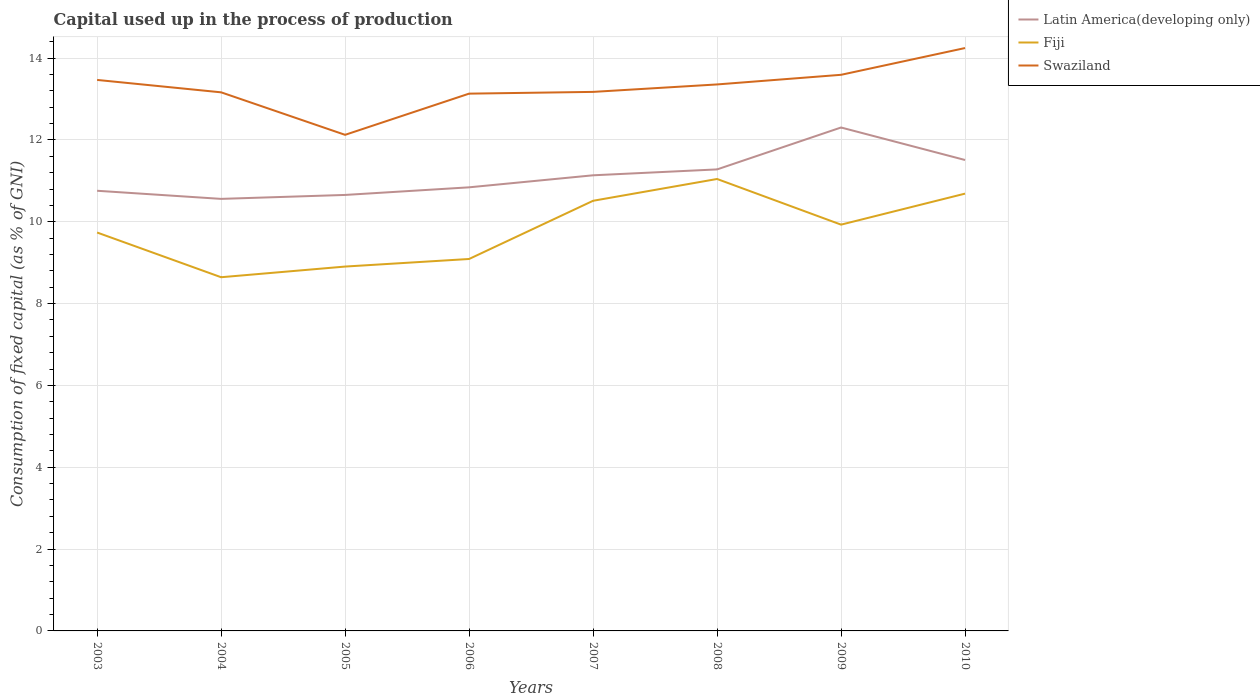Across all years, what is the maximum capital used up in the process of production in Latin America(developing only)?
Make the answer very short. 10.56. In which year was the capital used up in the process of production in Fiji maximum?
Offer a very short reply. 2004. What is the total capital used up in the process of production in Swaziland in the graph?
Your answer should be very brief. -0.23. What is the difference between the highest and the second highest capital used up in the process of production in Fiji?
Give a very brief answer. 2.4. What is the difference between the highest and the lowest capital used up in the process of production in Latin America(developing only)?
Give a very brief answer. 4. Is the capital used up in the process of production in Swaziland strictly greater than the capital used up in the process of production in Latin America(developing only) over the years?
Ensure brevity in your answer.  No. How many years are there in the graph?
Keep it short and to the point. 8. What is the title of the graph?
Your answer should be compact. Capital used up in the process of production. What is the label or title of the Y-axis?
Keep it short and to the point. Consumption of fixed capital (as % of GNI). What is the Consumption of fixed capital (as % of GNI) of Latin America(developing only) in 2003?
Ensure brevity in your answer.  10.76. What is the Consumption of fixed capital (as % of GNI) in Fiji in 2003?
Give a very brief answer. 9.74. What is the Consumption of fixed capital (as % of GNI) of Swaziland in 2003?
Keep it short and to the point. 13.47. What is the Consumption of fixed capital (as % of GNI) of Latin America(developing only) in 2004?
Give a very brief answer. 10.56. What is the Consumption of fixed capital (as % of GNI) in Fiji in 2004?
Ensure brevity in your answer.  8.64. What is the Consumption of fixed capital (as % of GNI) of Swaziland in 2004?
Your response must be concise. 13.16. What is the Consumption of fixed capital (as % of GNI) of Latin America(developing only) in 2005?
Offer a very short reply. 10.66. What is the Consumption of fixed capital (as % of GNI) of Fiji in 2005?
Give a very brief answer. 8.91. What is the Consumption of fixed capital (as % of GNI) of Swaziland in 2005?
Ensure brevity in your answer.  12.13. What is the Consumption of fixed capital (as % of GNI) in Latin America(developing only) in 2006?
Give a very brief answer. 10.84. What is the Consumption of fixed capital (as % of GNI) in Fiji in 2006?
Ensure brevity in your answer.  9.09. What is the Consumption of fixed capital (as % of GNI) of Swaziland in 2006?
Keep it short and to the point. 13.13. What is the Consumption of fixed capital (as % of GNI) in Latin America(developing only) in 2007?
Your response must be concise. 11.14. What is the Consumption of fixed capital (as % of GNI) in Fiji in 2007?
Offer a very short reply. 10.51. What is the Consumption of fixed capital (as % of GNI) of Swaziland in 2007?
Your response must be concise. 13.18. What is the Consumption of fixed capital (as % of GNI) in Latin America(developing only) in 2008?
Offer a very short reply. 11.28. What is the Consumption of fixed capital (as % of GNI) in Fiji in 2008?
Provide a succinct answer. 11.05. What is the Consumption of fixed capital (as % of GNI) in Swaziland in 2008?
Provide a short and direct response. 13.36. What is the Consumption of fixed capital (as % of GNI) of Latin America(developing only) in 2009?
Offer a terse response. 12.3. What is the Consumption of fixed capital (as % of GNI) of Fiji in 2009?
Your answer should be very brief. 9.93. What is the Consumption of fixed capital (as % of GNI) in Swaziland in 2009?
Your answer should be compact. 13.59. What is the Consumption of fixed capital (as % of GNI) of Latin America(developing only) in 2010?
Make the answer very short. 11.51. What is the Consumption of fixed capital (as % of GNI) in Fiji in 2010?
Offer a terse response. 10.69. What is the Consumption of fixed capital (as % of GNI) of Swaziland in 2010?
Keep it short and to the point. 14.25. Across all years, what is the maximum Consumption of fixed capital (as % of GNI) of Latin America(developing only)?
Keep it short and to the point. 12.3. Across all years, what is the maximum Consumption of fixed capital (as % of GNI) of Fiji?
Ensure brevity in your answer.  11.05. Across all years, what is the maximum Consumption of fixed capital (as % of GNI) of Swaziland?
Ensure brevity in your answer.  14.25. Across all years, what is the minimum Consumption of fixed capital (as % of GNI) of Latin America(developing only)?
Ensure brevity in your answer.  10.56. Across all years, what is the minimum Consumption of fixed capital (as % of GNI) of Fiji?
Offer a very short reply. 8.64. Across all years, what is the minimum Consumption of fixed capital (as % of GNI) in Swaziland?
Offer a very short reply. 12.13. What is the total Consumption of fixed capital (as % of GNI) in Latin America(developing only) in the graph?
Your answer should be very brief. 89.05. What is the total Consumption of fixed capital (as % of GNI) in Fiji in the graph?
Keep it short and to the point. 78.56. What is the total Consumption of fixed capital (as % of GNI) of Swaziland in the graph?
Keep it short and to the point. 106.26. What is the difference between the Consumption of fixed capital (as % of GNI) of Latin America(developing only) in 2003 and that in 2004?
Ensure brevity in your answer.  0.2. What is the difference between the Consumption of fixed capital (as % of GNI) of Fiji in 2003 and that in 2004?
Provide a succinct answer. 1.09. What is the difference between the Consumption of fixed capital (as % of GNI) of Swaziland in 2003 and that in 2004?
Make the answer very short. 0.3. What is the difference between the Consumption of fixed capital (as % of GNI) in Latin America(developing only) in 2003 and that in 2005?
Your response must be concise. 0.1. What is the difference between the Consumption of fixed capital (as % of GNI) of Fiji in 2003 and that in 2005?
Offer a very short reply. 0.83. What is the difference between the Consumption of fixed capital (as % of GNI) of Swaziland in 2003 and that in 2005?
Give a very brief answer. 1.34. What is the difference between the Consumption of fixed capital (as % of GNI) of Latin America(developing only) in 2003 and that in 2006?
Your answer should be very brief. -0.08. What is the difference between the Consumption of fixed capital (as % of GNI) of Fiji in 2003 and that in 2006?
Keep it short and to the point. 0.65. What is the difference between the Consumption of fixed capital (as % of GNI) in Swaziland in 2003 and that in 2006?
Provide a succinct answer. 0.34. What is the difference between the Consumption of fixed capital (as % of GNI) of Latin America(developing only) in 2003 and that in 2007?
Your answer should be very brief. -0.38. What is the difference between the Consumption of fixed capital (as % of GNI) in Fiji in 2003 and that in 2007?
Offer a terse response. -0.78. What is the difference between the Consumption of fixed capital (as % of GNI) of Swaziland in 2003 and that in 2007?
Provide a succinct answer. 0.29. What is the difference between the Consumption of fixed capital (as % of GNI) in Latin America(developing only) in 2003 and that in 2008?
Offer a terse response. -0.52. What is the difference between the Consumption of fixed capital (as % of GNI) in Fiji in 2003 and that in 2008?
Provide a short and direct response. -1.31. What is the difference between the Consumption of fixed capital (as % of GNI) in Swaziland in 2003 and that in 2008?
Make the answer very short. 0.11. What is the difference between the Consumption of fixed capital (as % of GNI) of Latin America(developing only) in 2003 and that in 2009?
Your answer should be very brief. -1.55. What is the difference between the Consumption of fixed capital (as % of GNI) of Fiji in 2003 and that in 2009?
Provide a succinct answer. -0.19. What is the difference between the Consumption of fixed capital (as % of GNI) of Swaziland in 2003 and that in 2009?
Provide a short and direct response. -0.13. What is the difference between the Consumption of fixed capital (as % of GNI) in Latin America(developing only) in 2003 and that in 2010?
Ensure brevity in your answer.  -0.75. What is the difference between the Consumption of fixed capital (as % of GNI) in Fiji in 2003 and that in 2010?
Provide a succinct answer. -0.95. What is the difference between the Consumption of fixed capital (as % of GNI) in Swaziland in 2003 and that in 2010?
Offer a very short reply. -0.78. What is the difference between the Consumption of fixed capital (as % of GNI) in Latin America(developing only) in 2004 and that in 2005?
Ensure brevity in your answer.  -0.1. What is the difference between the Consumption of fixed capital (as % of GNI) of Fiji in 2004 and that in 2005?
Provide a succinct answer. -0.26. What is the difference between the Consumption of fixed capital (as % of GNI) in Swaziland in 2004 and that in 2005?
Give a very brief answer. 1.04. What is the difference between the Consumption of fixed capital (as % of GNI) in Latin America(developing only) in 2004 and that in 2006?
Keep it short and to the point. -0.28. What is the difference between the Consumption of fixed capital (as % of GNI) in Fiji in 2004 and that in 2006?
Provide a short and direct response. -0.45. What is the difference between the Consumption of fixed capital (as % of GNI) of Swaziland in 2004 and that in 2006?
Offer a very short reply. 0.03. What is the difference between the Consumption of fixed capital (as % of GNI) in Latin America(developing only) in 2004 and that in 2007?
Give a very brief answer. -0.58. What is the difference between the Consumption of fixed capital (as % of GNI) of Fiji in 2004 and that in 2007?
Give a very brief answer. -1.87. What is the difference between the Consumption of fixed capital (as % of GNI) of Swaziland in 2004 and that in 2007?
Provide a succinct answer. -0.01. What is the difference between the Consumption of fixed capital (as % of GNI) of Latin America(developing only) in 2004 and that in 2008?
Provide a short and direct response. -0.72. What is the difference between the Consumption of fixed capital (as % of GNI) of Fiji in 2004 and that in 2008?
Provide a short and direct response. -2.4. What is the difference between the Consumption of fixed capital (as % of GNI) in Swaziland in 2004 and that in 2008?
Provide a succinct answer. -0.19. What is the difference between the Consumption of fixed capital (as % of GNI) of Latin America(developing only) in 2004 and that in 2009?
Provide a short and direct response. -1.74. What is the difference between the Consumption of fixed capital (as % of GNI) in Fiji in 2004 and that in 2009?
Provide a short and direct response. -1.29. What is the difference between the Consumption of fixed capital (as % of GNI) of Swaziland in 2004 and that in 2009?
Make the answer very short. -0.43. What is the difference between the Consumption of fixed capital (as % of GNI) of Latin America(developing only) in 2004 and that in 2010?
Your response must be concise. -0.95. What is the difference between the Consumption of fixed capital (as % of GNI) of Fiji in 2004 and that in 2010?
Your response must be concise. -2.04. What is the difference between the Consumption of fixed capital (as % of GNI) of Swaziland in 2004 and that in 2010?
Provide a succinct answer. -1.08. What is the difference between the Consumption of fixed capital (as % of GNI) in Latin America(developing only) in 2005 and that in 2006?
Your answer should be very brief. -0.19. What is the difference between the Consumption of fixed capital (as % of GNI) of Fiji in 2005 and that in 2006?
Provide a short and direct response. -0.18. What is the difference between the Consumption of fixed capital (as % of GNI) in Swaziland in 2005 and that in 2006?
Provide a succinct answer. -1.01. What is the difference between the Consumption of fixed capital (as % of GNI) of Latin America(developing only) in 2005 and that in 2007?
Keep it short and to the point. -0.48. What is the difference between the Consumption of fixed capital (as % of GNI) of Fiji in 2005 and that in 2007?
Your response must be concise. -1.61. What is the difference between the Consumption of fixed capital (as % of GNI) of Swaziland in 2005 and that in 2007?
Your response must be concise. -1.05. What is the difference between the Consumption of fixed capital (as % of GNI) of Latin America(developing only) in 2005 and that in 2008?
Provide a short and direct response. -0.62. What is the difference between the Consumption of fixed capital (as % of GNI) in Fiji in 2005 and that in 2008?
Provide a short and direct response. -2.14. What is the difference between the Consumption of fixed capital (as % of GNI) of Swaziland in 2005 and that in 2008?
Ensure brevity in your answer.  -1.23. What is the difference between the Consumption of fixed capital (as % of GNI) of Latin America(developing only) in 2005 and that in 2009?
Make the answer very short. -1.65. What is the difference between the Consumption of fixed capital (as % of GNI) of Fiji in 2005 and that in 2009?
Make the answer very short. -1.02. What is the difference between the Consumption of fixed capital (as % of GNI) in Swaziland in 2005 and that in 2009?
Give a very brief answer. -1.47. What is the difference between the Consumption of fixed capital (as % of GNI) of Latin America(developing only) in 2005 and that in 2010?
Offer a terse response. -0.85. What is the difference between the Consumption of fixed capital (as % of GNI) of Fiji in 2005 and that in 2010?
Provide a short and direct response. -1.78. What is the difference between the Consumption of fixed capital (as % of GNI) of Swaziland in 2005 and that in 2010?
Your answer should be very brief. -2.12. What is the difference between the Consumption of fixed capital (as % of GNI) of Latin America(developing only) in 2006 and that in 2007?
Your answer should be very brief. -0.29. What is the difference between the Consumption of fixed capital (as % of GNI) in Fiji in 2006 and that in 2007?
Offer a terse response. -1.42. What is the difference between the Consumption of fixed capital (as % of GNI) in Swaziland in 2006 and that in 2007?
Provide a short and direct response. -0.04. What is the difference between the Consumption of fixed capital (as % of GNI) in Latin America(developing only) in 2006 and that in 2008?
Offer a terse response. -0.44. What is the difference between the Consumption of fixed capital (as % of GNI) of Fiji in 2006 and that in 2008?
Give a very brief answer. -1.96. What is the difference between the Consumption of fixed capital (as % of GNI) in Swaziland in 2006 and that in 2008?
Ensure brevity in your answer.  -0.23. What is the difference between the Consumption of fixed capital (as % of GNI) in Latin America(developing only) in 2006 and that in 2009?
Ensure brevity in your answer.  -1.46. What is the difference between the Consumption of fixed capital (as % of GNI) of Fiji in 2006 and that in 2009?
Offer a very short reply. -0.84. What is the difference between the Consumption of fixed capital (as % of GNI) in Swaziland in 2006 and that in 2009?
Give a very brief answer. -0.46. What is the difference between the Consumption of fixed capital (as % of GNI) in Latin America(developing only) in 2006 and that in 2010?
Provide a succinct answer. -0.67. What is the difference between the Consumption of fixed capital (as % of GNI) in Fiji in 2006 and that in 2010?
Your response must be concise. -1.6. What is the difference between the Consumption of fixed capital (as % of GNI) in Swaziland in 2006 and that in 2010?
Your answer should be compact. -1.11. What is the difference between the Consumption of fixed capital (as % of GNI) in Latin America(developing only) in 2007 and that in 2008?
Your answer should be very brief. -0.14. What is the difference between the Consumption of fixed capital (as % of GNI) of Fiji in 2007 and that in 2008?
Make the answer very short. -0.53. What is the difference between the Consumption of fixed capital (as % of GNI) of Swaziland in 2007 and that in 2008?
Your answer should be compact. -0.18. What is the difference between the Consumption of fixed capital (as % of GNI) of Latin America(developing only) in 2007 and that in 2009?
Ensure brevity in your answer.  -1.17. What is the difference between the Consumption of fixed capital (as % of GNI) in Fiji in 2007 and that in 2009?
Offer a very short reply. 0.58. What is the difference between the Consumption of fixed capital (as % of GNI) of Swaziland in 2007 and that in 2009?
Your answer should be compact. -0.42. What is the difference between the Consumption of fixed capital (as % of GNI) in Latin America(developing only) in 2007 and that in 2010?
Provide a succinct answer. -0.37. What is the difference between the Consumption of fixed capital (as % of GNI) in Fiji in 2007 and that in 2010?
Your answer should be very brief. -0.17. What is the difference between the Consumption of fixed capital (as % of GNI) of Swaziland in 2007 and that in 2010?
Offer a terse response. -1.07. What is the difference between the Consumption of fixed capital (as % of GNI) of Latin America(developing only) in 2008 and that in 2009?
Offer a very short reply. -1.02. What is the difference between the Consumption of fixed capital (as % of GNI) of Fiji in 2008 and that in 2009?
Offer a very short reply. 1.12. What is the difference between the Consumption of fixed capital (as % of GNI) of Swaziland in 2008 and that in 2009?
Your answer should be very brief. -0.24. What is the difference between the Consumption of fixed capital (as % of GNI) of Latin America(developing only) in 2008 and that in 2010?
Provide a succinct answer. -0.23. What is the difference between the Consumption of fixed capital (as % of GNI) in Fiji in 2008 and that in 2010?
Provide a succinct answer. 0.36. What is the difference between the Consumption of fixed capital (as % of GNI) of Swaziland in 2008 and that in 2010?
Offer a terse response. -0.89. What is the difference between the Consumption of fixed capital (as % of GNI) of Latin America(developing only) in 2009 and that in 2010?
Your answer should be compact. 0.79. What is the difference between the Consumption of fixed capital (as % of GNI) in Fiji in 2009 and that in 2010?
Offer a terse response. -0.76. What is the difference between the Consumption of fixed capital (as % of GNI) of Swaziland in 2009 and that in 2010?
Your response must be concise. -0.65. What is the difference between the Consumption of fixed capital (as % of GNI) in Latin America(developing only) in 2003 and the Consumption of fixed capital (as % of GNI) in Fiji in 2004?
Ensure brevity in your answer.  2.11. What is the difference between the Consumption of fixed capital (as % of GNI) of Latin America(developing only) in 2003 and the Consumption of fixed capital (as % of GNI) of Swaziland in 2004?
Your answer should be very brief. -2.41. What is the difference between the Consumption of fixed capital (as % of GNI) in Fiji in 2003 and the Consumption of fixed capital (as % of GNI) in Swaziland in 2004?
Ensure brevity in your answer.  -3.43. What is the difference between the Consumption of fixed capital (as % of GNI) in Latin America(developing only) in 2003 and the Consumption of fixed capital (as % of GNI) in Fiji in 2005?
Your answer should be very brief. 1.85. What is the difference between the Consumption of fixed capital (as % of GNI) in Latin America(developing only) in 2003 and the Consumption of fixed capital (as % of GNI) in Swaziland in 2005?
Your response must be concise. -1.37. What is the difference between the Consumption of fixed capital (as % of GNI) in Fiji in 2003 and the Consumption of fixed capital (as % of GNI) in Swaziland in 2005?
Your response must be concise. -2.39. What is the difference between the Consumption of fixed capital (as % of GNI) of Latin America(developing only) in 2003 and the Consumption of fixed capital (as % of GNI) of Fiji in 2006?
Your answer should be very brief. 1.67. What is the difference between the Consumption of fixed capital (as % of GNI) in Latin America(developing only) in 2003 and the Consumption of fixed capital (as % of GNI) in Swaziland in 2006?
Your answer should be compact. -2.37. What is the difference between the Consumption of fixed capital (as % of GNI) in Fiji in 2003 and the Consumption of fixed capital (as % of GNI) in Swaziland in 2006?
Ensure brevity in your answer.  -3.39. What is the difference between the Consumption of fixed capital (as % of GNI) in Latin America(developing only) in 2003 and the Consumption of fixed capital (as % of GNI) in Fiji in 2007?
Your answer should be very brief. 0.24. What is the difference between the Consumption of fixed capital (as % of GNI) of Latin America(developing only) in 2003 and the Consumption of fixed capital (as % of GNI) of Swaziland in 2007?
Offer a terse response. -2.42. What is the difference between the Consumption of fixed capital (as % of GNI) in Fiji in 2003 and the Consumption of fixed capital (as % of GNI) in Swaziland in 2007?
Keep it short and to the point. -3.44. What is the difference between the Consumption of fixed capital (as % of GNI) of Latin America(developing only) in 2003 and the Consumption of fixed capital (as % of GNI) of Fiji in 2008?
Provide a short and direct response. -0.29. What is the difference between the Consumption of fixed capital (as % of GNI) in Latin America(developing only) in 2003 and the Consumption of fixed capital (as % of GNI) in Swaziland in 2008?
Keep it short and to the point. -2.6. What is the difference between the Consumption of fixed capital (as % of GNI) of Fiji in 2003 and the Consumption of fixed capital (as % of GNI) of Swaziland in 2008?
Provide a succinct answer. -3.62. What is the difference between the Consumption of fixed capital (as % of GNI) of Latin America(developing only) in 2003 and the Consumption of fixed capital (as % of GNI) of Fiji in 2009?
Your response must be concise. 0.83. What is the difference between the Consumption of fixed capital (as % of GNI) in Latin America(developing only) in 2003 and the Consumption of fixed capital (as % of GNI) in Swaziland in 2009?
Give a very brief answer. -2.83. What is the difference between the Consumption of fixed capital (as % of GNI) in Fiji in 2003 and the Consumption of fixed capital (as % of GNI) in Swaziland in 2009?
Give a very brief answer. -3.85. What is the difference between the Consumption of fixed capital (as % of GNI) in Latin America(developing only) in 2003 and the Consumption of fixed capital (as % of GNI) in Fiji in 2010?
Give a very brief answer. 0.07. What is the difference between the Consumption of fixed capital (as % of GNI) of Latin America(developing only) in 2003 and the Consumption of fixed capital (as % of GNI) of Swaziland in 2010?
Offer a terse response. -3.49. What is the difference between the Consumption of fixed capital (as % of GNI) in Fiji in 2003 and the Consumption of fixed capital (as % of GNI) in Swaziland in 2010?
Offer a terse response. -4.51. What is the difference between the Consumption of fixed capital (as % of GNI) in Latin America(developing only) in 2004 and the Consumption of fixed capital (as % of GNI) in Fiji in 2005?
Your answer should be compact. 1.65. What is the difference between the Consumption of fixed capital (as % of GNI) in Latin America(developing only) in 2004 and the Consumption of fixed capital (as % of GNI) in Swaziland in 2005?
Provide a succinct answer. -1.57. What is the difference between the Consumption of fixed capital (as % of GNI) of Fiji in 2004 and the Consumption of fixed capital (as % of GNI) of Swaziland in 2005?
Your answer should be very brief. -3.48. What is the difference between the Consumption of fixed capital (as % of GNI) in Latin America(developing only) in 2004 and the Consumption of fixed capital (as % of GNI) in Fiji in 2006?
Give a very brief answer. 1.47. What is the difference between the Consumption of fixed capital (as % of GNI) of Latin America(developing only) in 2004 and the Consumption of fixed capital (as % of GNI) of Swaziland in 2006?
Make the answer very short. -2.57. What is the difference between the Consumption of fixed capital (as % of GNI) in Fiji in 2004 and the Consumption of fixed capital (as % of GNI) in Swaziland in 2006?
Your response must be concise. -4.49. What is the difference between the Consumption of fixed capital (as % of GNI) of Latin America(developing only) in 2004 and the Consumption of fixed capital (as % of GNI) of Fiji in 2007?
Provide a succinct answer. 0.05. What is the difference between the Consumption of fixed capital (as % of GNI) of Latin America(developing only) in 2004 and the Consumption of fixed capital (as % of GNI) of Swaziland in 2007?
Make the answer very short. -2.62. What is the difference between the Consumption of fixed capital (as % of GNI) in Fiji in 2004 and the Consumption of fixed capital (as % of GNI) in Swaziland in 2007?
Offer a very short reply. -4.53. What is the difference between the Consumption of fixed capital (as % of GNI) of Latin America(developing only) in 2004 and the Consumption of fixed capital (as % of GNI) of Fiji in 2008?
Provide a succinct answer. -0.49. What is the difference between the Consumption of fixed capital (as % of GNI) of Latin America(developing only) in 2004 and the Consumption of fixed capital (as % of GNI) of Swaziland in 2008?
Offer a terse response. -2.8. What is the difference between the Consumption of fixed capital (as % of GNI) in Fiji in 2004 and the Consumption of fixed capital (as % of GNI) in Swaziland in 2008?
Offer a terse response. -4.71. What is the difference between the Consumption of fixed capital (as % of GNI) of Latin America(developing only) in 2004 and the Consumption of fixed capital (as % of GNI) of Fiji in 2009?
Your answer should be compact. 0.63. What is the difference between the Consumption of fixed capital (as % of GNI) in Latin America(developing only) in 2004 and the Consumption of fixed capital (as % of GNI) in Swaziland in 2009?
Ensure brevity in your answer.  -3.03. What is the difference between the Consumption of fixed capital (as % of GNI) of Fiji in 2004 and the Consumption of fixed capital (as % of GNI) of Swaziland in 2009?
Offer a very short reply. -4.95. What is the difference between the Consumption of fixed capital (as % of GNI) of Latin America(developing only) in 2004 and the Consumption of fixed capital (as % of GNI) of Fiji in 2010?
Make the answer very short. -0.13. What is the difference between the Consumption of fixed capital (as % of GNI) in Latin America(developing only) in 2004 and the Consumption of fixed capital (as % of GNI) in Swaziland in 2010?
Offer a very short reply. -3.69. What is the difference between the Consumption of fixed capital (as % of GNI) in Fiji in 2004 and the Consumption of fixed capital (as % of GNI) in Swaziland in 2010?
Give a very brief answer. -5.6. What is the difference between the Consumption of fixed capital (as % of GNI) in Latin America(developing only) in 2005 and the Consumption of fixed capital (as % of GNI) in Fiji in 2006?
Give a very brief answer. 1.57. What is the difference between the Consumption of fixed capital (as % of GNI) of Latin America(developing only) in 2005 and the Consumption of fixed capital (as % of GNI) of Swaziland in 2006?
Keep it short and to the point. -2.48. What is the difference between the Consumption of fixed capital (as % of GNI) in Fiji in 2005 and the Consumption of fixed capital (as % of GNI) in Swaziland in 2006?
Your answer should be compact. -4.23. What is the difference between the Consumption of fixed capital (as % of GNI) in Latin America(developing only) in 2005 and the Consumption of fixed capital (as % of GNI) in Fiji in 2007?
Give a very brief answer. 0.14. What is the difference between the Consumption of fixed capital (as % of GNI) of Latin America(developing only) in 2005 and the Consumption of fixed capital (as % of GNI) of Swaziland in 2007?
Your response must be concise. -2.52. What is the difference between the Consumption of fixed capital (as % of GNI) of Fiji in 2005 and the Consumption of fixed capital (as % of GNI) of Swaziland in 2007?
Your response must be concise. -4.27. What is the difference between the Consumption of fixed capital (as % of GNI) in Latin America(developing only) in 2005 and the Consumption of fixed capital (as % of GNI) in Fiji in 2008?
Offer a very short reply. -0.39. What is the difference between the Consumption of fixed capital (as % of GNI) of Latin America(developing only) in 2005 and the Consumption of fixed capital (as % of GNI) of Swaziland in 2008?
Provide a short and direct response. -2.7. What is the difference between the Consumption of fixed capital (as % of GNI) of Fiji in 2005 and the Consumption of fixed capital (as % of GNI) of Swaziland in 2008?
Provide a short and direct response. -4.45. What is the difference between the Consumption of fixed capital (as % of GNI) of Latin America(developing only) in 2005 and the Consumption of fixed capital (as % of GNI) of Fiji in 2009?
Your answer should be compact. 0.73. What is the difference between the Consumption of fixed capital (as % of GNI) of Latin America(developing only) in 2005 and the Consumption of fixed capital (as % of GNI) of Swaziland in 2009?
Provide a succinct answer. -2.94. What is the difference between the Consumption of fixed capital (as % of GNI) of Fiji in 2005 and the Consumption of fixed capital (as % of GNI) of Swaziland in 2009?
Your response must be concise. -4.69. What is the difference between the Consumption of fixed capital (as % of GNI) in Latin America(developing only) in 2005 and the Consumption of fixed capital (as % of GNI) in Fiji in 2010?
Make the answer very short. -0.03. What is the difference between the Consumption of fixed capital (as % of GNI) of Latin America(developing only) in 2005 and the Consumption of fixed capital (as % of GNI) of Swaziland in 2010?
Make the answer very short. -3.59. What is the difference between the Consumption of fixed capital (as % of GNI) in Fiji in 2005 and the Consumption of fixed capital (as % of GNI) in Swaziland in 2010?
Make the answer very short. -5.34. What is the difference between the Consumption of fixed capital (as % of GNI) of Latin America(developing only) in 2006 and the Consumption of fixed capital (as % of GNI) of Fiji in 2007?
Make the answer very short. 0.33. What is the difference between the Consumption of fixed capital (as % of GNI) in Latin America(developing only) in 2006 and the Consumption of fixed capital (as % of GNI) in Swaziland in 2007?
Offer a very short reply. -2.33. What is the difference between the Consumption of fixed capital (as % of GNI) of Fiji in 2006 and the Consumption of fixed capital (as % of GNI) of Swaziland in 2007?
Provide a succinct answer. -4.08. What is the difference between the Consumption of fixed capital (as % of GNI) of Latin America(developing only) in 2006 and the Consumption of fixed capital (as % of GNI) of Fiji in 2008?
Offer a terse response. -0.2. What is the difference between the Consumption of fixed capital (as % of GNI) in Latin America(developing only) in 2006 and the Consumption of fixed capital (as % of GNI) in Swaziland in 2008?
Keep it short and to the point. -2.51. What is the difference between the Consumption of fixed capital (as % of GNI) of Fiji in 2006 and the Consumption of fixed capital (as % of GNI) of Swaziland in 2008?
Your answer should be compact. -4.27. What is the difference between the Consumption of fixed capital (as % of GNI) in Latin America(developing only) in 2006 and the Consumption of fixed capital (as % of GNI) in Fiji in 2009?
Offer a terse response. 0.91. What is the difference between the Consumption of fixed capital (as % of GNI) of Latin America(developing only) in 2006 and the Consumption of fixed capital (as % of GNI) of Swaziland in 2009?
Provide a succinct answer. -2.75. What is the difference between the Consumption of fixed capital (as % of GNI) of Fiji in 2006 and the Consumption of fixed capital (as % of GNI) of Swaziland in 2009?
Offer a very short reply. -4.5. What is the difference between the Consumption of fixed capital (as % of GNI) in Latin America(developing only) in 2006 and the Consumption of fixed capital (as % of GNI) in Fiji in 2010?
Offer a terse response. 0.15. What is the difference between the Consumption of fixed capital (as % of GNI) of Latin America(developing only) in 2006 and the Consumption of fixed capital (as % of GNI) of Swaziland in 2010?
Provide a succinct answer. -3.4. What is the difference between the Consumption of fixed capital (as % of GNI) of Fiji in 2006 and the Consumption of fixed capital (as % of GNI) of Swaziland in 2010?
Your answer should be compact. -5.16. What is the difference between the Consumption of fixed capital (as % of GNI) of Latin America(developing only) in 2007 and the Consumption of fixed capital (as % of GNI) of Fiji in 2008?
Ensure brevity in your answer.  0.09. What is the difference between the Consumption of fixed capital (as % of GNI) in Latin America(developing only) in 2007 and the Consumption of fixed capital (as % of GNI) in Swaziland in 2008?
Keep it short and to the point. -2.22. What is the difference between the Consumption of fixed capital (as % of GNI) in Fiji in 2007 and the Consumption of fixed capital (as % of GNI) in Swaziland in 2008?
Offer a terse response. -2.84. What is the difference between the Consumption of fixed capital (as % of GNI) in Latin America(developing only) in 2007 and the Consumption of fixed capital (as % of GNI) in Fiji in 2009?
Your answer should be very brief. 1.21. What is the difference between the Consumption of fixed capital (as % of GNI) of Latin America(developing only) in 2007 and the Consumption of fixed capital (as % of GNI) of Swaziland in 2009?
Your response must be concise. -2.46. What is the difference between the Consumption of fixed capital (as % of GNI) in Fiji in 2007 and the Consumption of fixed capital (as % of GNI) in Swaziland in 2009?
Give a very brief answer. -3.08. What is the difference between the Consumption of fixed capital (as % of GNI) in Latin America(developing only) in 2007 and the Consumption of fixed capital (as % of GNI) in Fiji in 2010?
Provide a short and direct response. 0.45. What is the difference between the Consumption of fixed capital (as % of GNI) in Latin America(developing only) in 2007 and the Consumption of fixed capital (as % of GNI) in Swaziland in 2010?
Offer a terse response. -3.11. What is the difference between the Consumption of fixed capital (as % of GNI) in Fiji in 2007 and the Consumption of fixed capital (as % of GNI) in Swaziland in 2010?
Your answer should be very brief. -3.73. What is the difference between the Consumption of fixed capital (as % of GNI) of Latin America(developing only) in 2008 and the Consumption of fixed capital (as % of GNI) of Fiji in 2009?
Provide a short and direct response. 1.35. What is the difference between the Consumption of fixed capital (as % of GNI) of Latin America(developing only) in 2008 and the Consumption of fixed capital (as % of GNI) of Swaziland in 2009?
Offer a terse response. -2.31. What is the difference between the Consumption of fixed capital (as % of GNI) of Fiji in 2008 and the Consumption of fixed capital (as % of GNI) of Swaziland in 2009?
Your response must be concise. -2.55. What is the difference between the Consumption of fixed capital (as % of GNI) of Latin America(developing only) in 2008 and the Consumption of fixed capital (as % of GNI) of Fiji in 2010?
Make the answer very short. 0.59. What is the difference between the Consumption of fixed capital (as % of GNI) in Latin America(developing only) in 2008 and the Consumption of fixed capital (as % of GNI) in Swaziland in 2010?
Offer a very short reply. -2.97. What is the difference between the Consumption of fixed capital (as % of GNI) in Fiji in 2008 and the Consumption of fixed capital (as % of GNI) in Swaziland in 2010?
Provide a succinct answer. -3.2. What is the difference between the Consumption of fixed capital (as % of GNI) in Latin America(developing only) in 2009 and the Consumption of fixed capital (as % of GNI) in Fiji in 2010?
Your response must be concise. 1.62. What is the difference between the Consumption of fixed capital (as % of GNI) of Latin America(developing only) in 2009 and the Consumption of fixed capital (as % of GNI) of Swaziland in 2010?
Your answer should be very brief. -1.94. What is the difference between the Consumption of fixed capital (as % of GNI) in Fiji in 2009 and the Consumption of fixed capital (as % of GNI) in Swaziland in 2010?
Offer a terse response. -4.32. What is the average Consumption of fixed capital (as % of GNI) of Latin America(developing only) per year?
Make the answer very short. 11.13. What is the average Consumption of fixed capital (as % of GNI) in Fiji per year?
Keep it short and to the point. 9.82. What is the average Consumption of fixed capital (as % of GNI) in Swaziland per year?
Keep it short and to the point. 13.28. In the year 2003, what is the difference between the Consumption of fixed capital (as % of GNI) in Latin America(developing only) and Consumption of fixed capital (as % of GNI) in Fiji?
Give a very brief answer. 1.02. In the year 2003, what is the difference between the Consumption of fixed capital (as % of GNI) in Latin America(developing only) and Consumption of fixed capital (as % of GNI) in Swaziland?
Your answer should be compact. -2.71. In the year 2003, what is the difference between the Consumption of fixed capital (as % of GNI) of Fiji and Consumption of fixed capital (as % of GNI) of Swaziland?
Offer a very short reply. -3.73. In the year 2004, what is the difference between the Consumption of fixed capital (as % of GNI) of Latin America(developing only) and Consumption of fixed capital (as % of GNI) of Fiji?
Offer a very short reply. 1.92. In the year 2004, what is the difference between the Consumption of fixed capital (as % of GNI) of Latin America(developing only) and Consumption of fixed capital (as % of GNI) of Swaziland?
Your answer should be compact. -2.6. In the year 2004, what is the difference between the Consumption of fixed capital (as % of GNI) in Fiji and Consumption of fixed capital (as % of GNI) in Swaziland?
Give a very brief answer. -4.52. In the year 2005, what is the difference between the Consumption of fixed capital (as % of GNI) of Latin America(developing only) and Consumption of fixed capital (as % of GNI) of Fiji?
Provide a succinct answer. 1.75. In the year 2005, what is the difference between the Consumption of fixed capital (as % of GNI) in Latin America(developing only) and Consumption of fixed capital (as % of GNI) in Swaziland?
Your answer should be compact. -1.47. In the year 2005, what is the difference between the Consumption of fixed capital (as % of GNI) in Fiji and Consumption of fixed capital (as % of GNI) in Swaziland?
Offer a very short reply. -3.22. In the year 2006, what is the difference between the Consumption of fixed capital (as % of GNI) in Latin America(developing only) and Consumption of fixed capital (as % of GNI) in Fiji?
Keep it short and to the point. 1.75. In the year 2006, what is the difference between the Consumption of fixed capital (as % of GNI) of Latin America(developing only) and Consumption of fixed capital (as % of GNI) of Swaziland?
Keep it short and to the point. -2.29. In the year 2006, what is the difference between the Consumption of fixed capital (as % of GNI) in Fiji and Consumption of fixed capital (as % of GNI) in Swaziland?
Offer a very short reply. -4.04. In the year 2007, what is the difference between the Consumption of fixed capital (as % of GNI) of Latin America(developing only) and Consumption of fixed capital (as % of GNI) of Fiji?
Give a very brief answer. 0.62. In the year 2007, what is the difference between the Consumption of fixed capital (as % of GNI) in Latin America(developing only) and Consumption of fixed capital (as % of GNI) in Swaziland?
Your response must be concise. -2.04. In the year 2007, what is the difference between the Consumption of fixed capital (as % of GNI) of Fiji and Consumption of fixed capital (as % of GNI) of Swaziland?
Ensure brevity in your answer.  -2.66. In the year 2008, what is the difference between the Consumption of fixed capital (as % of GNI) in Latin America(developing only) and Consumption of fixed capital (as % of GNI) in Fiji?
Provide a succinct answer. 0.23. In the year 2008, what is the difference between the Consumption of fixed capital (as % of GNI) of Latin America(developing only) and Consumption of fixed capital (as % of GNI) of Swaziland?
Make the answer very short. -2.08. In the year 2008, what is the difference between the Consumption of fixed capital (as % of GNI) of Fiji and Consumption of fixed capital (as % of GNI) of Swaziland?
Provide a succinct answer. -2.31. In the year 2009, what is the difference between the Consumption of fixed capital (as % of GNI) in Latin America(developing only) and Consumption of fixed capital (as % of GNI) in Fiji?
Make the answer very short. 2.37. In the year 2009, what is the difference between the Consumption of fixed capital (as % of GNI) in Latin America(developing only) and Consumption of fixed capital (as % of GNI) in Swaziland?
Give a very brief answer. -1.29. In the year 2009, what is the difference between the Consumption of fixed capital (as % of GNI) of Fiji and Consumption of fixed capital (as % of GNI) of Swaziland?
Provide a short and direct response. -3.66. In the year 2010, what is the difference between the Consumption of fixed capital (as % of GNI) in Latin America(developing only) and Consumption of fixed capital (as % of GNI) in Fiji?
Ensure brevity in your answer.  0.82. In the year 2010, what is the difference between the Consumption of fixed capital (as % of GNI) in Latin America(developing only) and Consumption of fixed capital (as % of GNI) in Swaziland?
Your answer should be very brief. -2.74. In the year 2010, what is the difference between the Consumption of fixed capital (as % of GNI) in Fiji and Consumption of fixed capital (as % of GNI) in Swaziland?
Make the answer very short. -3.56. What is the ratio of the Consumption of fixed capital (as % of GNI) in Latin America(developing only) in 2003 to that in 2004?
Offer a very short reply. 1.02. What is the ratio of the Consumption of fixed capital (as % of GNI) of Fiji in 2003 to that in 2004?
Provide a succinct answer. 1.13. What is the ratio of the Consumption of fixed capital (as % of GNI) of Latin America(developing only) in 2003 to that in 2005?
Make the answer very short. 1.01. What is the ratio of the Consumption of fixed capital (as % of GNI) in Fiji in 2003 to that in 2005?
Your answer should be compact. 1.09. What is the ratio of the Consumption of fixed capital (as % of GNI) in Swaziland in 2003 to that in 2005?
Keep it short and to the point. 1.11. What is the ratio of the Consumption of fixed capital (as % of GNI) in Latin America(developing only) in 2003 to that in 2006?
Your response must be concise. 0.99. What is the ratio of the Consumption of fixed capital (as % of GNI) in Fiji in 2003 to that in 2006?
Offer a very short reply. 1.07. What is the ratio of the Consumption of fixed capital (as % of GNI) of Swaziland in 2003 to that in 2006?
Provide a short and direct response. 1.03. What is the ratio of the Consumption of fixed capital (as % of GNI) in Fiji in 2003 to that in 2007?
Offer a terse response. 0.93. What is the ratio of the Consumption of fixed capital (as % of GNI) of Swaziland in 2003 to that in 2007?
Give a very brief answer. 1.02. What is the ratio of the Consumption of fixed capital (as % of GNI) of Latin America(developing only) in 2003 to that in 2008?
Offer a terse response. 0.95. What is the ratio of the Consumption of fixed capital (as % of GNI) in Fiji in 2003 to that in 2008?
Your answer should be compact. 0.88. What is the ratio of the Consumption of fixed capital (as % of GNI) of Swaziland in 2003 to that in 2008?
Give a very brief answer. 1.01. What is the ratio of the Consumption of fixed capital (as % of GNI) of Latin America(developing only) in 2003 to that in 2009?
Offer a very short reply. 0.87. What is the ratio of the Consumption of fixed capital (as % of GNI) in Fiji in 2003 to that in 2009?
Ensure brevity in your answer.  0.98. What is the ratio of the Consumption of fixed capital (as % of GNI) of Latin America(developing only) in 2003 to that in 2010?
Your answer should be very brief. 0.93. What is the ratio of the Consumption of fixed capital (as % of GNI) in Fiji in 2003 to that in 2010?
Your answer should be compact. 0.91. What is the ratio of the Consumption of fixed capital (as % of GNI) of Swaziland in 2003 to that in 2010?
Offer a terse response. 0.95. What is the ratio of the Consumption of fixed capital (as % of GNI) in Latin America(developing only) in 2004 to that in 2005?
Your answer should be compact. 0.99. What is the ratio of the Consumption of fixed capital (as % of GNI) of Fiji in 2004 to that in 2005?
Your answer should be compact. 0.97. What is the ratio of the Consumption of fixed capital (as % of GNI) of Swaziland in 2004 to that in 2005?
Offer a terse response. 1.09. What is the ratio of the Consumption of fixed capital (as % of GNI) in Latin America(developing only) in 2004 to that in 2006?
Ensure brevity in your answer.  0.97. What is the ratio of the Consumption of fixed capital (as % of GNI) of Fiji in 2004 to that in 2006?
Your answer should be very brief. 0.95. What is the ratio of the Consumption of fixed capital (as % of GNI) in Latin America(developing only) in 2004 to that in 2007?
Your answer should be very brief. 0.95. What is the ratio of the Consumption of fixed capital (as % of GNI) of Fiji in 2004 to that in 2007?
Provide a short and direct response. 0.82. What is the ratio of the Consumption of fixed capital (as % of GNI) of Latin America(developing only) in 2004 to that in 2008?
Offer a terse response. 0.94. What is the ratio of the Consumption of fixed capital (as % of GNI) in Fiji in 2004 to that in 2008?
Give a very brief answer. 0.78. What is the ratio of the Consumption of fixed capital (as % of GNI) in Swaziland in 2004 to that in 2008?
Ensure brevity in your answer.  0.99. What is the ratio of the Consumption of fixed capital (as % of GNI) of Latin America(developing only) in 2004 to that in 2009?
Offer a terse response. 0.86. What is the ratio of the Consumption of fixed capital (as % of GNI) of Fiji in 2004 to that in 2009?
Your answer should be compact. 0.87. What is the ratio of the Consumption of fixed capital (as % of GNI) in Swaziland in 2004 to that in 2009?
Your answer should be very brief. 0.97. What is the ratio of the Consumption of fixed capital (as % of GNI) of Latin America(developing only) in 2004 to that in 2010?
Ensure brevity in your answer.  0.92. What is the ratio of the Consumption of fixed capital (as % of GNI) of Fiji in 2004 to that in 2010?
Your answer should be very brief. 0.81. What is the ratio of the Consumption of fixed capital (as % of GNI) in Swaziland in 2004 to that in 2010?
Offer a terse response. 0.92. What is the ratio of the Consumption of fixed capital (as % of GNI) in Latin America(developing only) in 2005 to that in 2006?
Offer a terse response. 0.98. What is the ratio of the Consumption of fixed capital (as % of GNI) of Fiji in 2005 to that in 2006?
Your answer should be very brief. 0.98. What is the ratio of the Consumption of fixed capital (as % of GNI) of Swaziland in 2005 to that in 2006?
Offer a terse response. 0.92. What is the ratio of the Consumption of fixed capital (as % of GNI) in Latin America(developing only) in 2005 to that in 2007?
Your response must be concise. 0.96. What is the ratio of the Consumption of fixed capital (as % of GNI) of Fiji in 2005 to that in 2007?
Your response must be concise. 0.85. What is the ratio of the Consumption of fixed capital (as % of GNI) of Swaziland in 2005 to that in 2007?
Give a very brief answer. 0.92. What is the ratio of the Consumption of fixed capital (as % of GNI) in Latin America(developing only) in 2005 to that in 2008?
Offer a terse response. 0.94. What is the ratio of the Consumption of fixed capital (as % of GNI) in Fiji in 2005 to that in 2008?
Provide a succinct answer. 0.81. What is the ratio of the Consumption of fixed capital (as % of GNI) in Swaziland in 2005 to that in 2008?
Offer a very short reply. 0.91. What is the ratio of the Consumption of fixed capital (as % of GNI) of Latin America(developing only) in 2005 to that in 2009?
Give a very brief answer. 0.87. What is the ratio of the Consumption of fixed capital (as % of GNI) of Fiji in 2005 to that in 2009?
Provide a succinct answer. 0.9. What is the ratio of the Consumption of fixed capital (as % of GNI) in Swaziland in 2005 to that in 2009?
Keep it short and to the point. 0.89. What is the ratio of the Consumption of fixed capital (as % of GNI) of Latin America(developing only) in 2005 to that in 2010?
Give a very brief answer. 0.93. What is the ratio of the Consumption of fixed capital (as % of GNI) of Fiji in 2005 to that in 2010?
Offer a terse response. 0.83. What is the ratio of the Consumption of fixed capital (as % of GNI) of Swaziland in 2005 to that in 2010?
Offer a terse response. 0.85. What is the ratio of the Consumption of fixed capital (as % of GNI) in Latin America(developing only) in 2006 to that in 2007?
Your answer should be very brief. 0.97. What is the ratio of the Consumption of fixed capital (as % of GNI) in Fiji in 2006 to that in 2007?
Provide a succinct answer. 0.86. What is the ratio of the Consumption of fixed capital (as % of GNI) of Latin America(developing only) in 2006 to that in 2008?
Your response must be concise. 0.96. What is the ratio of the Consumption of fixed capital (as % of GNI) in Fiji in 2006 to that in 2008?
Offer a very short reply. 0.82. What is the ratio of the Consumption of fixed capital (as % of GNI) in Swaziland in 2006 to that in 2008?
Give a very brief answer. 0.98. What is the ratio of the Consumption of fixed capital (as % of GNI) of Latin America(developing only) in 2006 to that in 2009?
Keep it short and to the point. 0.88. What is the ratio of the Consumption of fixed capital (as % of GNI) in Fiji in 2006 to that in 2009?
Offer a very short reply. 0.92. What is the ratio of the Consumption of fixed capital (as % of GNI) of Swaziland in 2006 to that in 2009?
Provide a short and direct response. 0.97. What is the ratio of the Consumption of fixed capital (as % of GNI) in Latin America(developing only) in 2006 to that in 2010?
Ensure brevity in your answer.  0.94. What is the ratio of the Consumption of fixed capital (as % of GNI) in Fiji in 2006 to that in 2010?
Your answer should be very brief. 0.85. What is the ratio of the Consumption of fixed capital (as % of GNI) of Swaziland in 2006 to that in 2010?
Give a very brief answer. 0.92. What is the ratio of the Consumption of fixed capital (as % of GNI) of Latin America(developing only) in 2007 to that in 2008?
Provide a succinct answer. 0.99. What is the ratio of the Consumption of fixed capital (as % of GNI) of Fiji in 2007 to that in 2008?
Keep it short and to the point. 0.95. What is the ratio of the Consumption of fixed capital (as % of GNI) of Swaziland in 2007 to that in 2008?
Provide a short and direct response. 0.99. What is the ratio of the Consumption of fixed capital (as % of GNI) of Latin America(developing only) in 2007 to that in 2009?
Your response must be concise. 0.91. What is the ratio of the Consumption of fixed capital (as % of GNI) in Fiji in 2007 to that in 2009?
Offer a terse response. 1.06. What is the ratio of the Consumption of fixed capital (as % of GNI) in Swaziland in 2007 to that in 2009?
Offer a very short reply. 0.97. What is the ratio of the Consumption of fixed capital (as % of GNI) in Latin America(developing only) in 2007 to that in 2010?
Keep it short and to the point. 0.97. What is the ratio of the Consumption of fixed capital (as % of GNI) in Fiji in 2007 to that in 2010?
Your answer should be compact. 0.98. What is the ratio of the Consumption of fixed capital (as % of GNI) of Swaziland in 2007 to that in 2010?
Make the answer very short. 0.92. What is the ratio of the Consumption of fixed capital (as % of GNI) in Latin America(developing only) in 2008 to that in 2009?
Provide a short and direct response. 0.92. What is the ratio of the Consumption of fixed capital (as % of GNI) in Fiji in 2008 to that in 2009?
Offer a very short reply. 1.11. What is the ratio of the Consumption of fixed capital (as % of GNI) in Swaziland in 2008 to that in 2009?
Ensure brevity in your answer.  0.98. What is the ratio of the Consumption of fixed capital (as % of GNI) of Latin America(developing only) in 2008 to that in 2010?
Keep it short and to the point. 0.98. What is the ratio of the Consumption of fixed capital (as % of GNI) in Fiji in 2008 to that in 2010?
Your answer should be very brief. 1.03. What is the ratio of the Consumption of fixed capital (as % of GNI) in Swaziland in 2008 to that in 2010?
Offer a terse response. 0.94. What is the ratio of the Consumption of fixed capital (as % of GNI) in Latin America(developing only) in 2009 to that in 2010?
Ensure brevity in your answer.  1.07. What is the ratio of the Consumption of fixed capital (as % of GNI) in Fiji in 2009 to that in 2010?
Provide a short and direct response. 0.93. What is the ratio of the Consumption of fixed capital (as % of GNI) of Swaziland in 2009 to that in 2010?
Your response must be concise. 0.95. What is the difference between the highest and the second highest Consumption of fixed capital (as % of GNI) in Latin America(developing only)?
Your answer should be compact. 0.79. What is the difference between the highest and the second highest Consumption of fixed capital (as % of GNI) of Fiji?
Offer a very short reply. 0.36. What is the difference between the highest and the second highest Consumption of fixed capital (as % of GNI) in Swaziland?
Your answer should be very brief. 0.65. What is the difference between the highest and the lowest Consumption of fixed capital (as % of GNI) in Latin America(developing only)?
Your answer should be very brief. 1.74. What is the difference between the highest and the lowest Consumption of fixed capital (as % of GNI) of Fiji?
Offer a very short reply. 2.4. What is the difference between the highest and the lowest Consumption of fixed capital (as % of GNI) in Swaziland?
Your answer should be very brief. 2.12. 